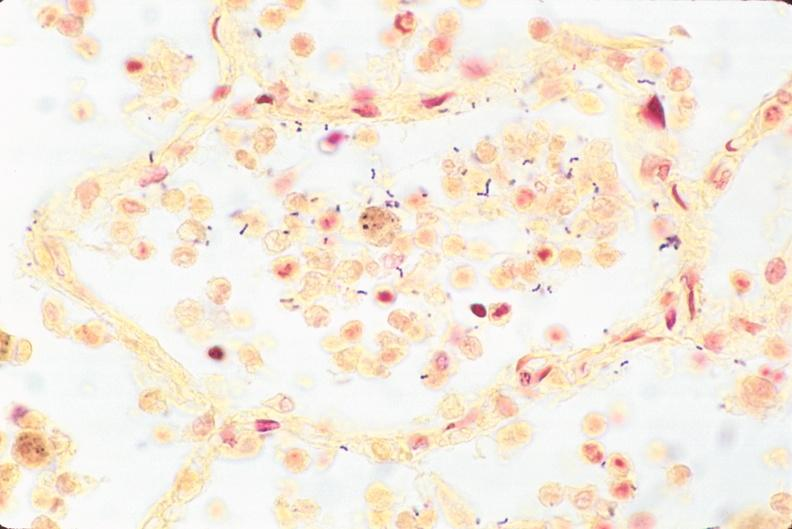do this image shows lung, bronchopneumonia, bacterial, tissue gram stain?
Answer the question using a single word or phrase. Yes 